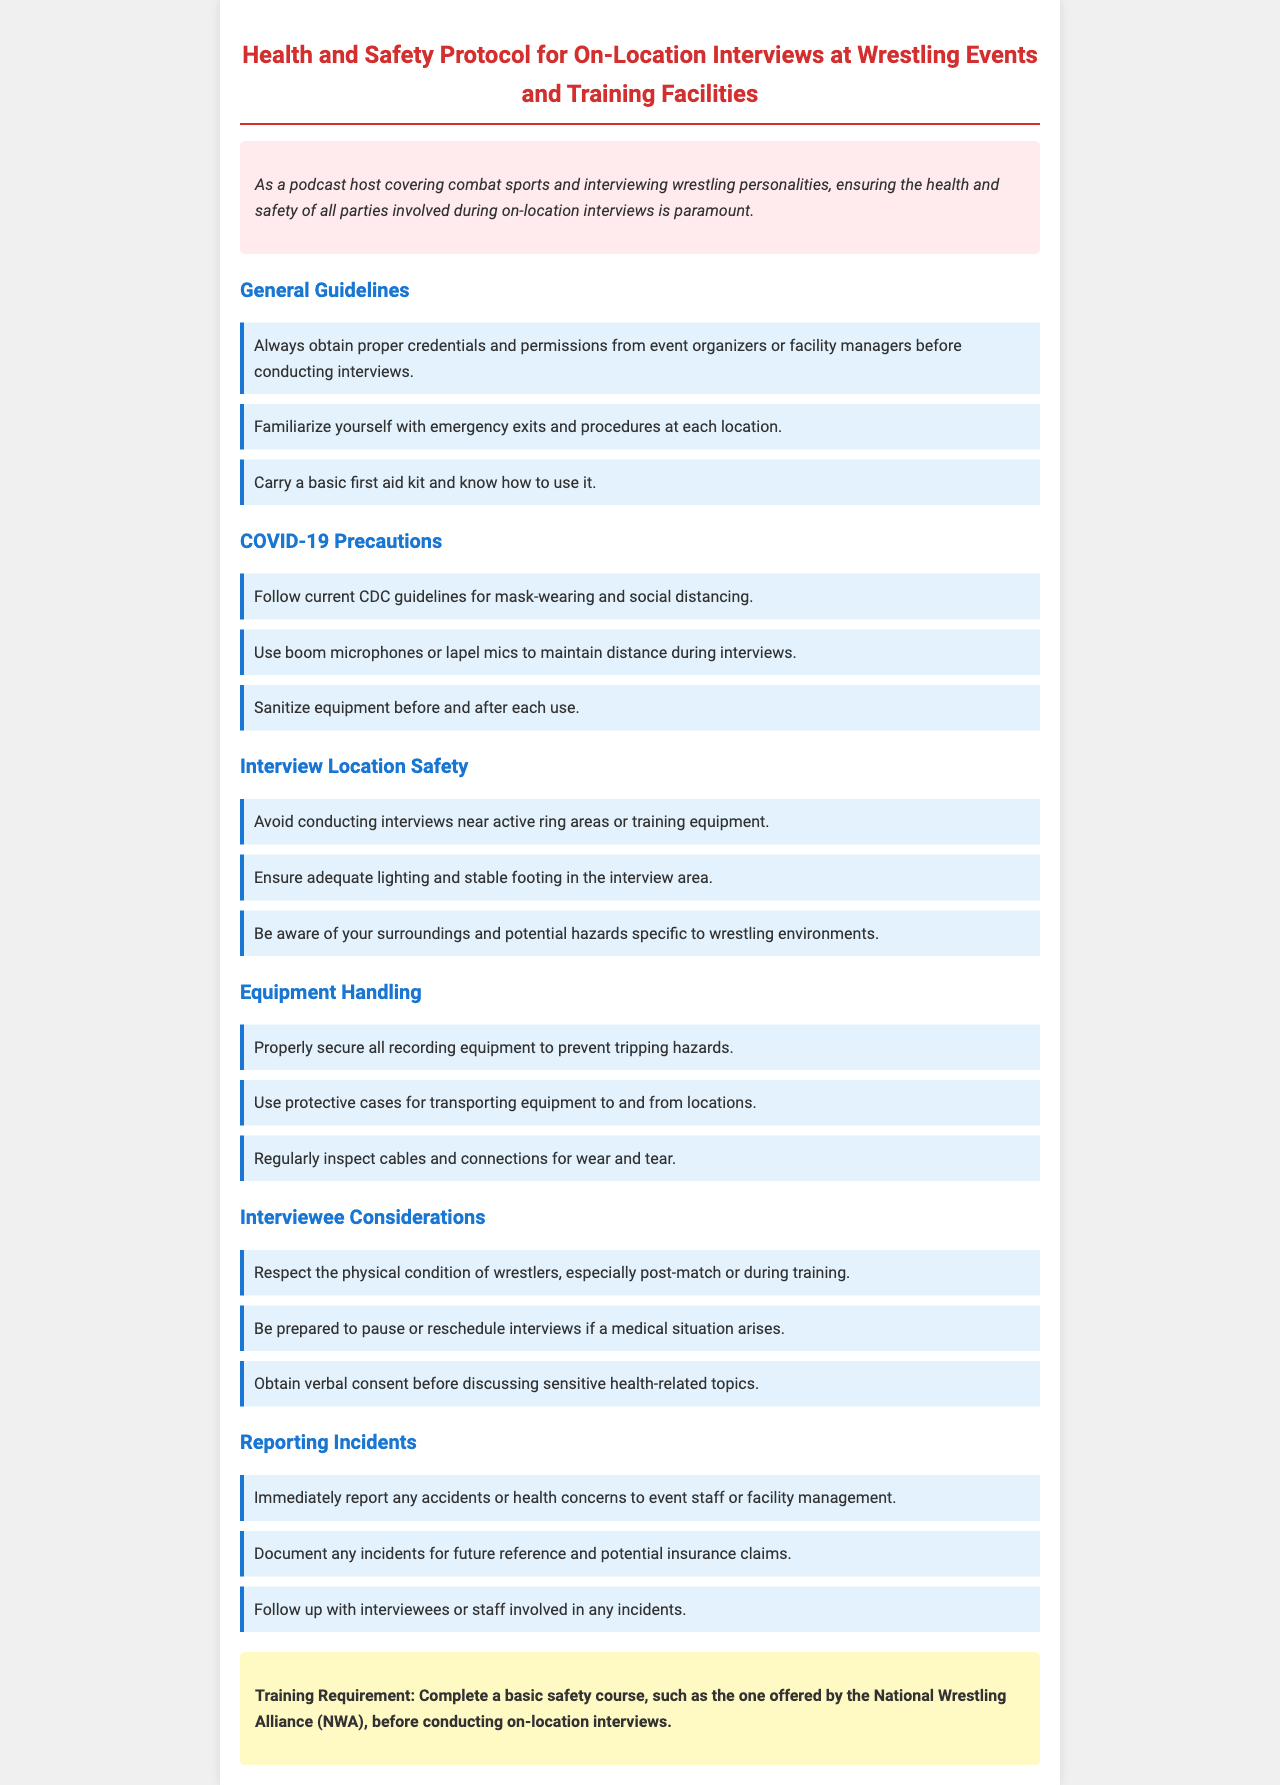what is the title of the document? The title is explicitly stated at the top of the document, which is about health and safety protocols for wrestling interviews.
Answer: Health and Safety Protocol for On-Location Interviews at Wrestling Events and Training Facilities what should you carry during on-location interviews? The document specifically mentions the necessity of a basic first aid kit for safety during interviews.
Answer: basic first aid kit what must be completed before conducting interviews? The training requirement mentioned in the document indicates the prerequisite for conducting interviews.
Answer: basic safety course what does the document suggest to maintain during interviews? The guidelines specifically mention distancing measures like using boom microphones during interviews.
Answer: social distancing how should recording equipment be secured? The document specifies a safety measure regarding the proper securing of equipment to avoid hazards.
Answer: properly secure all recording equipment what should be done if a medical situation arises? An important protocol highlighted in the document refers to actions to take regarding interviews during medical incidents.
Answer: pause or reschedule interviews how often should cables and connections be inspected? The document implies regular checks as an important safety step concerning equipment.
Answer: regularly what is the color of the precaution section regarding COVID-19? The document describes the color used for the COVID-19 precautions, reflecting its importance through a visual cue.
Answer: blue 